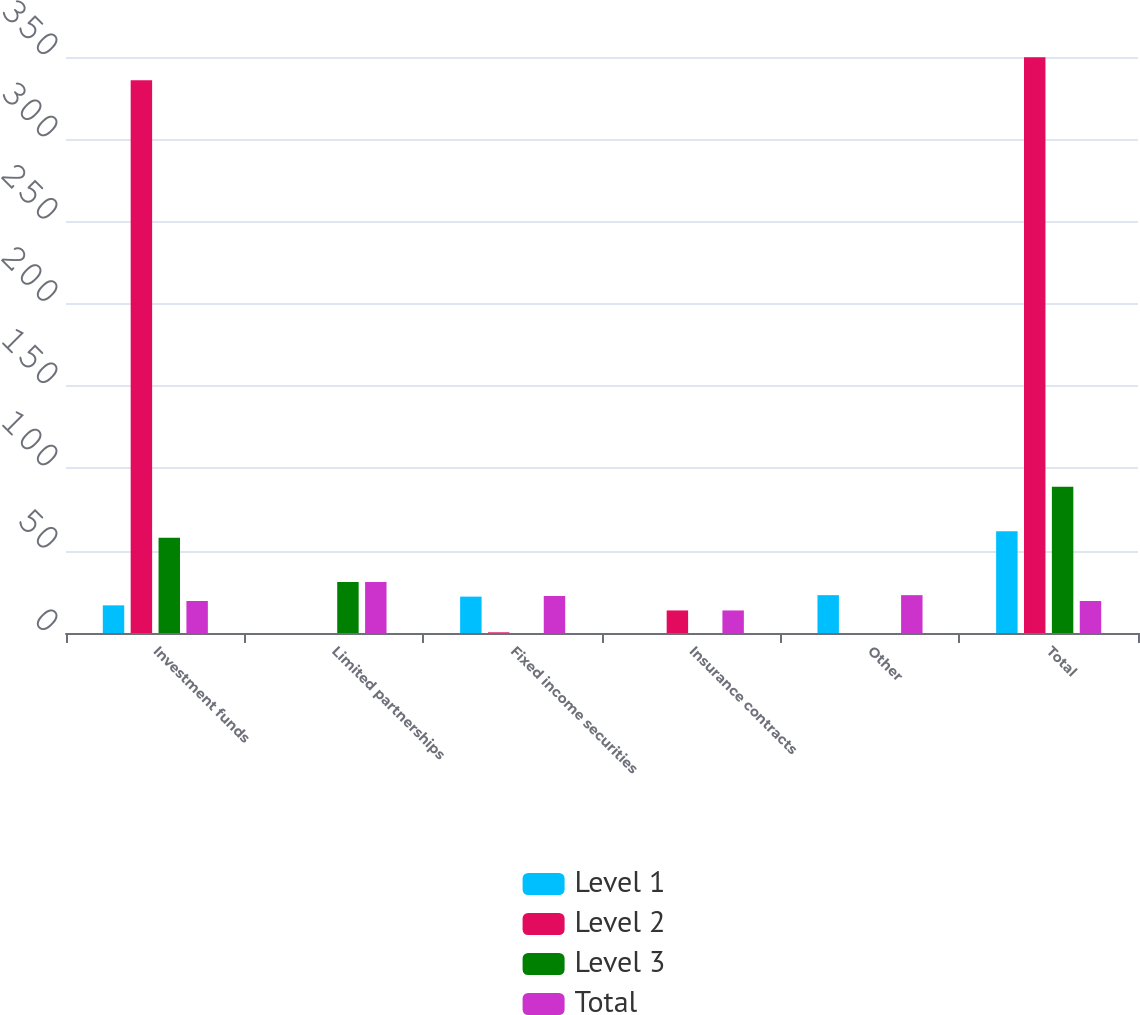Convert chart. <chart><loc_0><loc_0><loc_500><loc_500><stacked_bar_chart><ecel><fcel>Investment funds<fcel>Limited partnerships<fcel>Fixed income securities<fcel>Insurance contracts<fcel>Other<fcel>Total<nl><fcel>Level 1<fcel>16.8<fcel>0<fcel>22.1<fcel>0<fcel>23<fcel>61.9<nl><fcel>Level 2<fcel>335.8<fcel>0<fcel>0.4<fcel>13.7<fcel>0<fcel>349.9<nl><fcel>Level 3<fcel>57.9<fcel>31<fcel>0<fcel>0<fcel>0<fcel>88.9<nl><fcel>Total<fcel>19.45<fcel>31<fcel>22.5<fcel>13.7<fcel>23<fcel>19.45<nl></chart> 